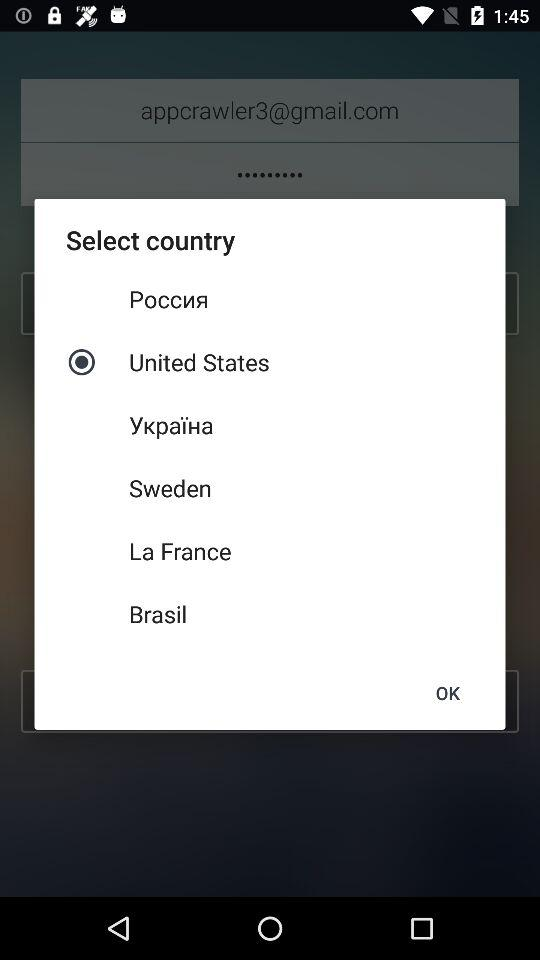What is the selected country? The selected country is the United States. 